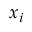Convert formula to latex. <formula><loc_0><loc_0><loc_500><loc_500>x _ { i }</formula> 